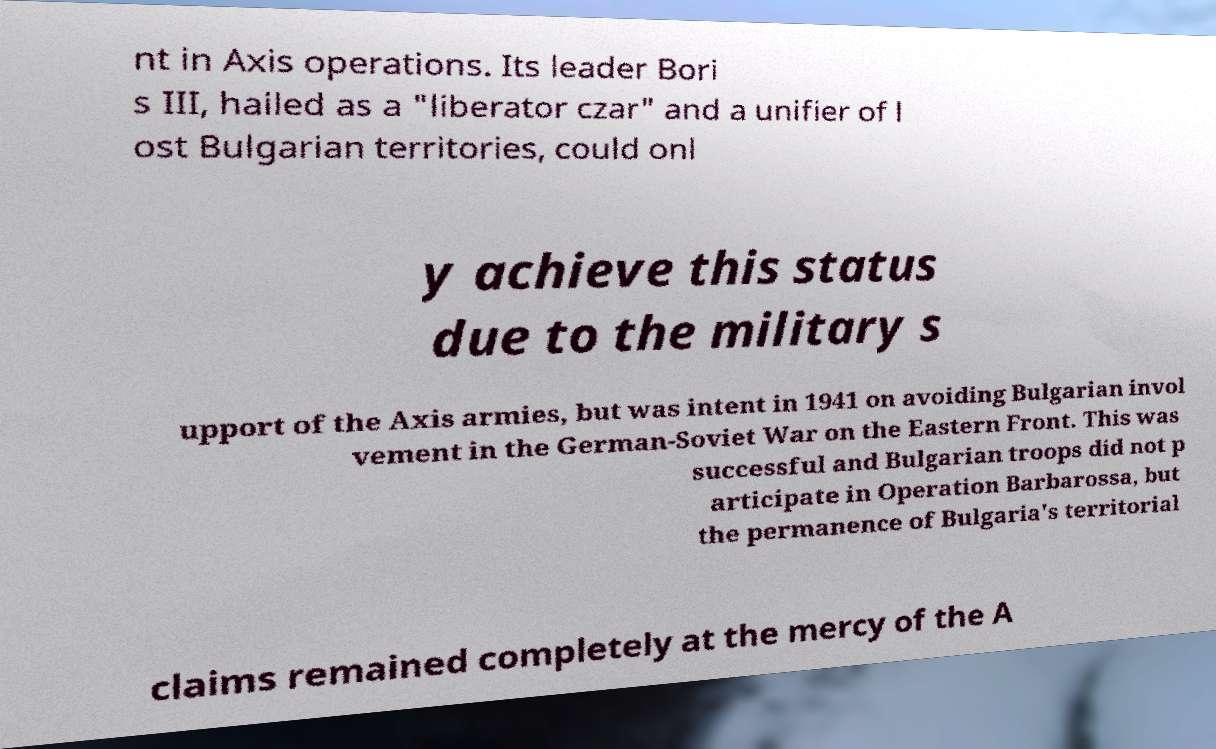There's text embedded in this image that I need extracted. Can you transcribe it verbatim? nt in Axis operations. Its leader Bori s III, hailed as a "liberator czar" and a unifier of l ost Bulgarian territories, could onl y achieve this status due to the military s upport of the Axis armies, but was intent in 1941 on avoiding Bulgarian invol vement in the German-Soviet War on the Eastern Front. This was successful and Bulgarian troops did not p articipate in Operation Barbarossa, but the permanence of Bulgaria's territorial claims remained completely at the mercy of the A 